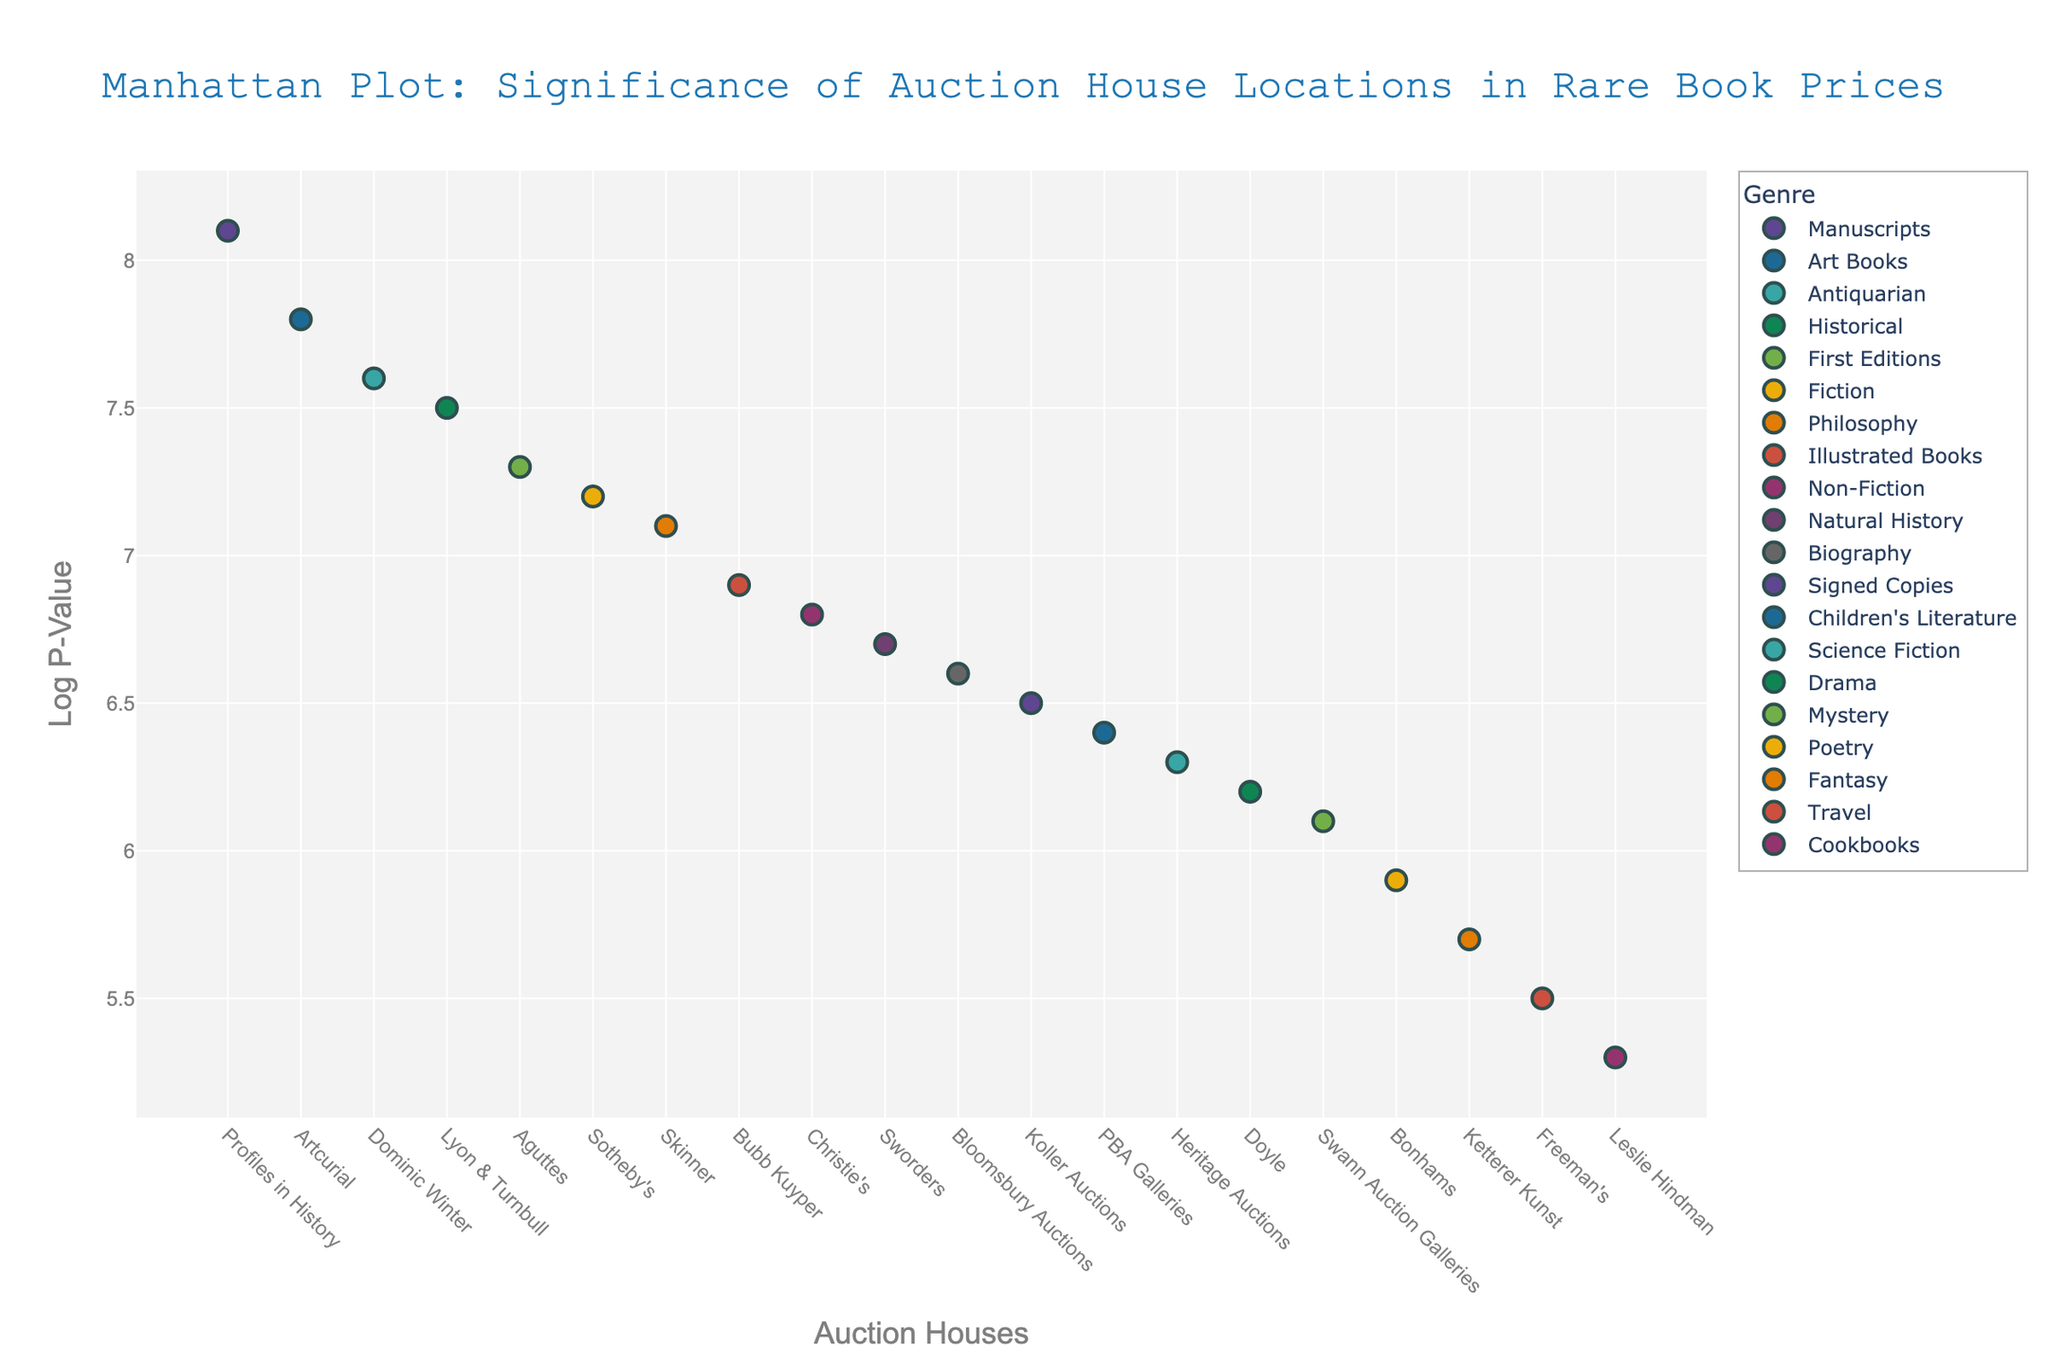How many genres are represented in the plot? Count the number of unique genres in the legend.
Answer: 20 Which genre has the highest LogP-Value and what is its value? Look for the highest point on the y-axis and read off the associated genre and value from the hover text.
Answer: Manuscripts, 8.1 What is the range of LogP-Values for auction houses in New York? Identify all points for New York, then find the difference between the highest and lowest LogP-Values.
Answer: 7.2 - 6.1 How do the LogP-Values of auction houses in London compare to those in Paris? Compare the height of points marked London and Paris on the y-axis.
Answer: London: 6.8, 6.6; Paris: 7.8, 7.3. Paris generally has higher values Which auction house in the U.S. has the lowest LogP-Value and what is it? Identify U.S. auction houses, then find the lowest point and read off the value and name.
Answer: Leslie Hindman (Chicago), 5.3 What is the average LogP-Value of the points associated with New York? Sum the LogP-Values for New York and divide by the number of data points. Values: 7.2, 6.1, 6.2. Average = (7.2 + 6.1 + 6.2) / 3 = 19.5 / 3 = 6.5.
Answer: 6.5 Which city has the most auction houses represented and how many? Count the number of times each city appears as hover text, then find the maximum count.
Answer: New York, 3 Is there any city that has auction houses with more than one genre represented? If yes, name the city and the genres. Look for cities with multiple points and note the genres from the hover text.
Answer: London; Genres: Non-Fiction, Biography What is the LogP-Value difference between the auction houses with the highest and lowest values? Identify the highest and lowest LogP-Values and subtract the lowest from the highest.
Answer: 8.1 - 5.3 = 2.8 Which genre represented by an auction house in Los Angeles has the higher LogP-Value? Look at the points for Los Angeles and compare their LogP-Values.
Answer: Manuscripts, 8.1 